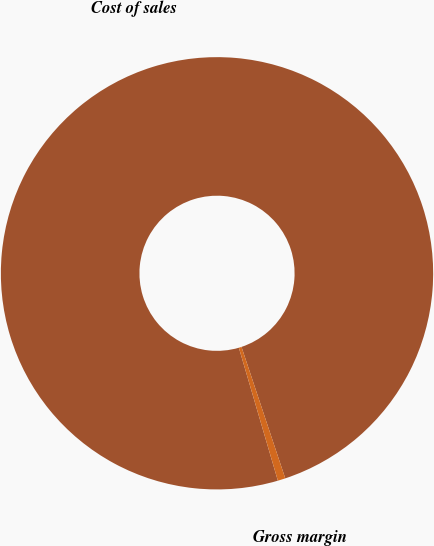Convert chart. <chart><loc_0><loc_0><loc_500><loc_500><pie_chart><fcel>Cost of sales<fcel>Gross margin<nl><fcel>99.43%<fcel>0.57%<nl></chart> 